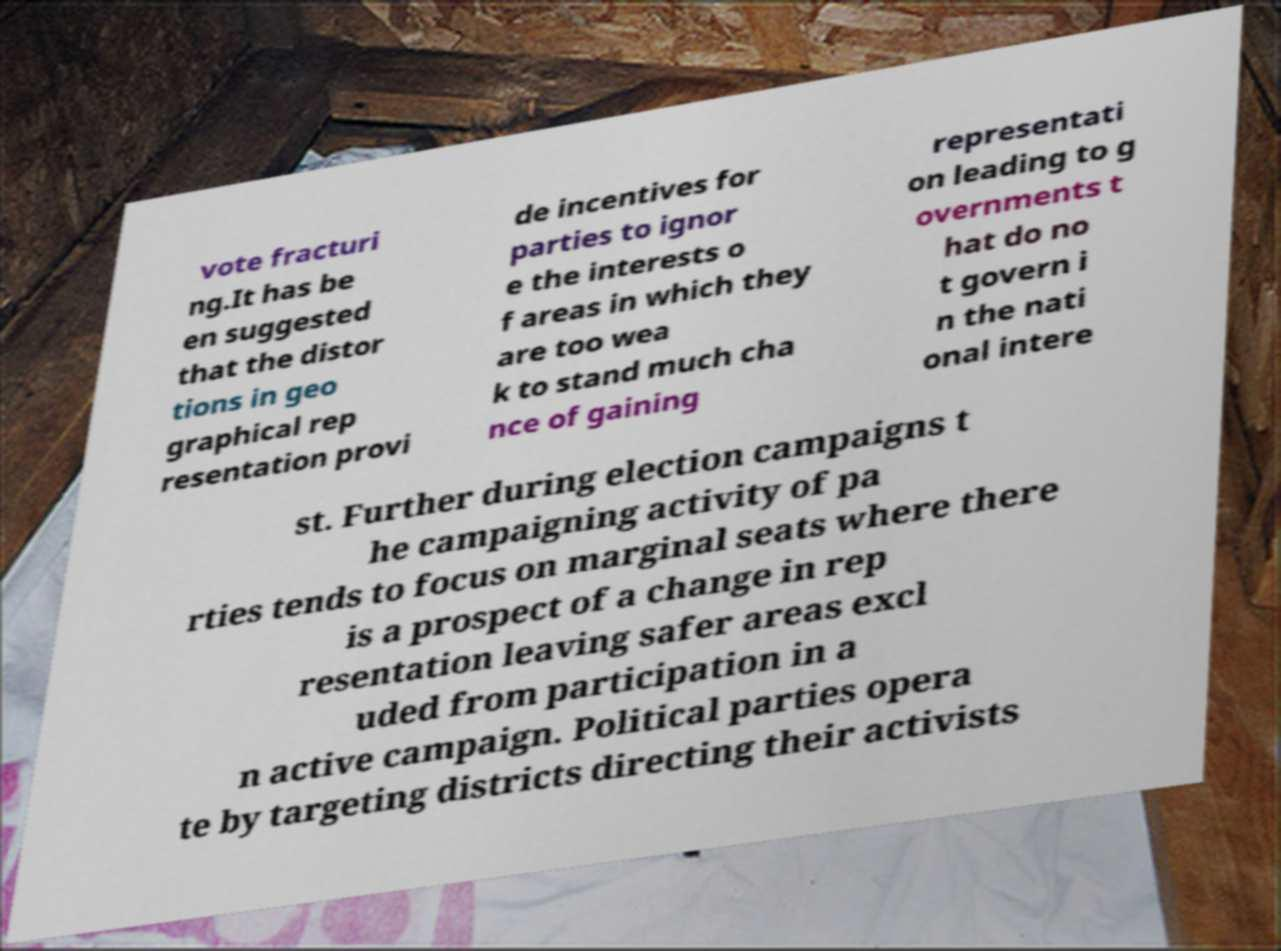Could you extract and type out the text from this image? vote fracturi ng.It has be en suggested that the distor tions in geo graphical rep resentation provi de incentives for parties to ignor e the interests o f areas in which they are too wea k to stand much cha nce of gaining representati on leading to g overnments t hat do no t govern i n the nati onal intere st. Further during election campaigns t he campaigning activity of pa rties tends to focus on marginal seats where there is a prospect of a change in rep resentation leaving safer areas excl uded from participation in a n active campaign. Political parties opera te by targeting districts directing their activists 